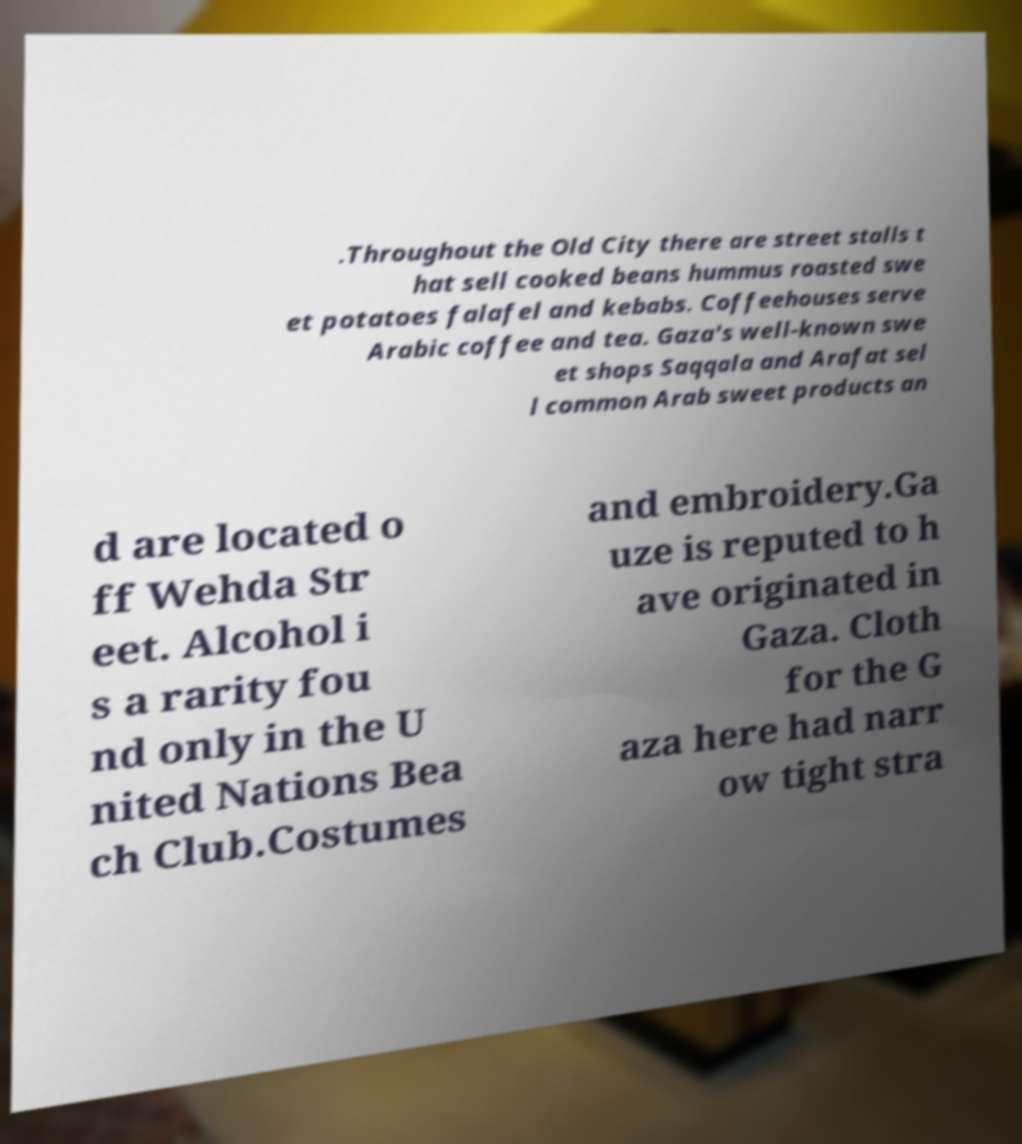Please identify and transcribe the text found in this image. .Throughout the Old City there are street stalls t hat sell cooked beans hummus roasted swe et potatoes falafel and kebabs. Coffeehouses serve Arabic coffee and tea. Gaza's well-known swe et shops Saqqala and Arafat sel l common Arab sweet products an d are located o ff Wehda Str eet. Alcohol i s a rarity fou nd only in the U nited Nations Bea ch Club.Costumes and embroidery.Ga uze is reputed to h ave originated in Gaza. Cloth for the G aza here had narr ow tight stra 